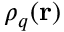<formula> <loc_0><loc_0><loc_500><loc_500>\rho _ { q } ( r )</formula> 